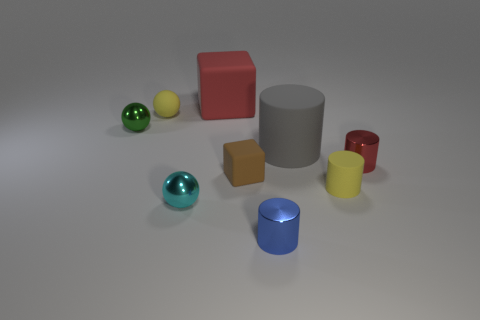Subtract 2 spheres. How many spheres are left? 1 Subtract all tiny cylinders. How many cylinders are left? 1 Subtract all red blocks. How many blocks are left? 1 Subtract all blocks. How many objects are left? 7 Subtract all yellow cylinders. How many green balls are left? 1 Subtract all cyan objects. Subtract all tiny yellow rubber objects. How many objects are left? 6 Add 2 red matte blocks. How many red matte blocks are left? 3 Add 2 tiny green blocks. How many tiny green blocks exist? 2 Add 1 small green spheres. How many objects exist? 10 Subtract 1 red cylinders. How many objects are left? 8 